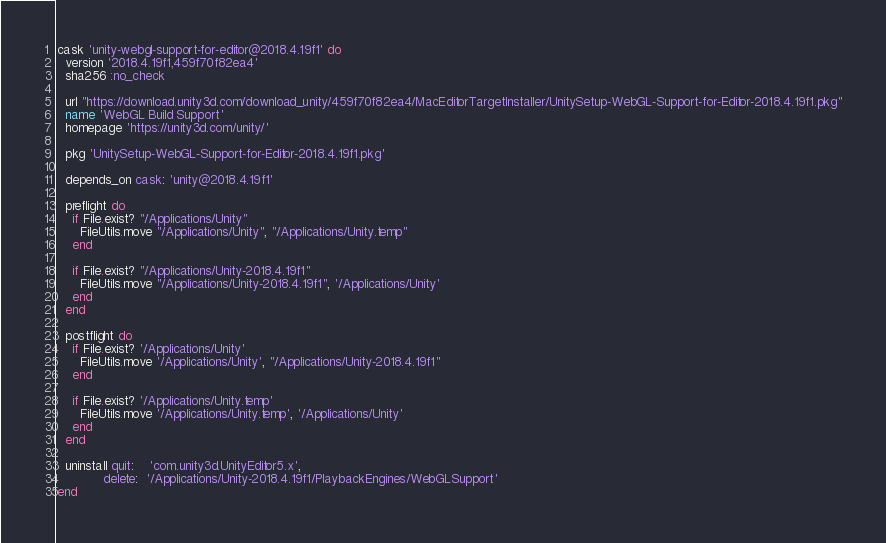Convert code to text. <code><loc_0><loc_0><loc_500><loc_500><_Ruby_>cask 'unity-webgl-support-for-editor@2018.4.19f1' do
  version '2018.4.19f1,459f70f82ea4'
  sha256 :no_check

  url "https://download.unity3d.com/download_unity/459f70f82ea4/MacEditorTargetInstaller/UnitySetup-WebGL-Support-for-Editor-2018.4.19f1.pkg"
  name 'WebGL Build Support'
  homepage 'https://unity3d.com/unity/'

  pkg 'UnitySetup-WebGL-Support-for-Editor-2018.4.19f1.pkg'

  depends_on cask: 'unity@2018.4.19f1'

  preflight do
    if File.exist? "/Applications/Unity"
      FileUtils.move "/Applications/Unity", "/Applications/Unity.temp"
    end

    if File.exist? "/Applications/Unity-2018.4.19f1"
      FileUtils.move "/Applications/Unity-2018.4.19f1", '/Applications/Unity'
    end
  end

  postflight do
    if File.exist? '/Applications/Unity'
      FileUtils.move '/Applications/Unity', "/Applications/Unity-2018.4.19f1"
    end

    if File.exist? '/Applications/Unity.temp'
      FileUtils.move '/Applications/Unity.temp', '/Applications/Unity'
    end
  end

  uninstall quit:    'com.unity3d.UnityEditor5.x',
            delete:  '/Applications/Unity-2018.4.19f1/PlaybackEngines/WebGLSupport'
end
</code> 